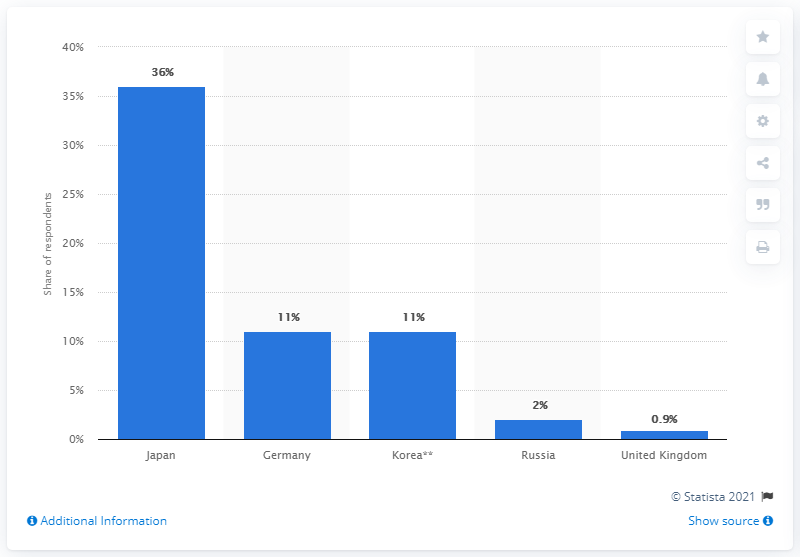Draw attention to some important aspects in this diagram. In the survey, it was found that a significant percentage of customers trusted German and Korean manufacturers. Specifically, 11% of customers indicated that they trusted German manufacturers, while 9% trusted Korean manufacturers. These findings suggest that these manufacturers have established a strong reputation for quality and reliability among customers. According to a recent survey, a significant percentage of Russians consider the national vehicle production to be the most reliable. 